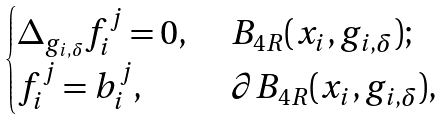Convert formula to latex. <formula><loc_0><loc_0><loc_500><loc_500>\begin{cases} \Delta _ { g _ { i , \delta } } f _ { i } ^ { j } = 0 , & \ B _ { 4 R } ( x _ { i } , g _ { i , \delta } ) ; \\ f _ { i } ^ { j } = b _ { i } ^ { j } , & \ \partial B _ { 4 R } ( x _ { i } , g _ { i , \delta } ) , \end{cases}</formula> 